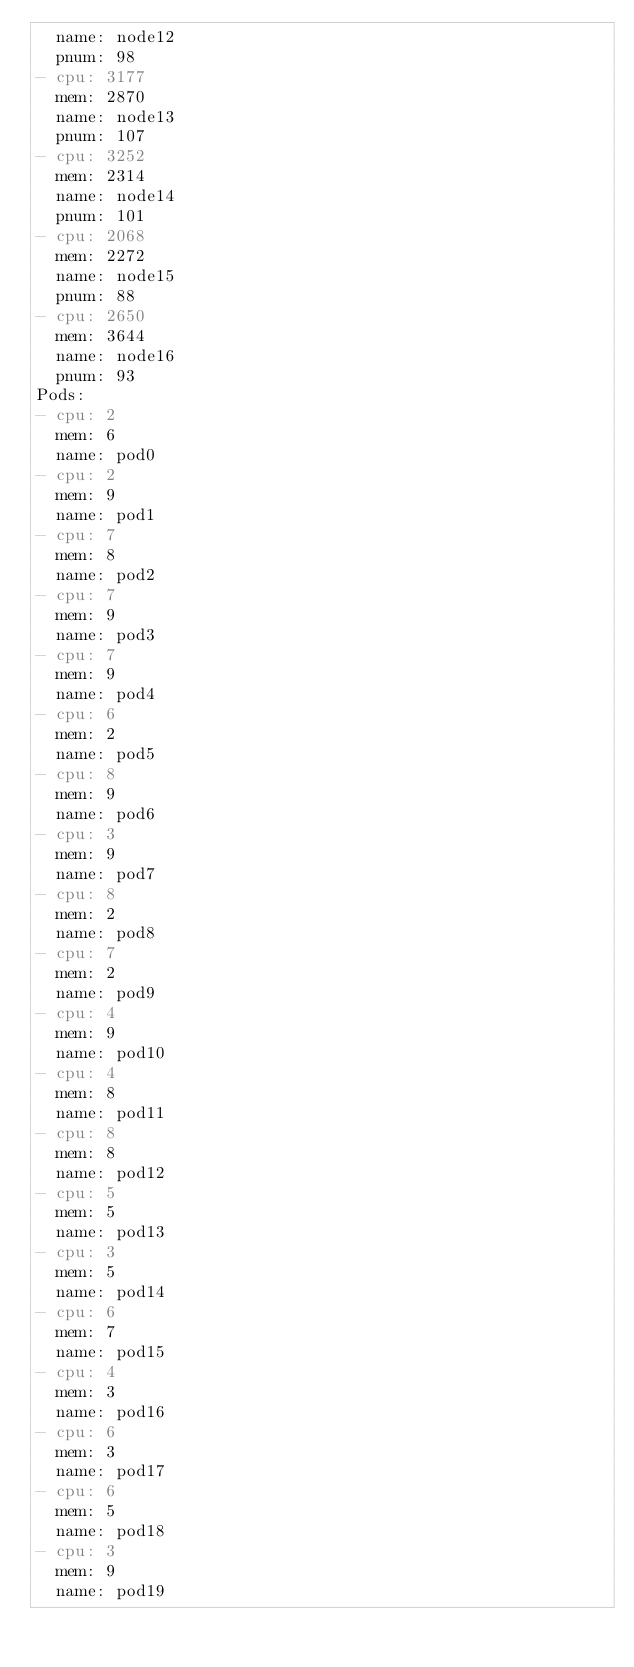Convert code to text. <code><loc_0><loc_0><loc_500><loc_500><_YAML_>  name: node12
  pnum: 98
- cpu: 3177
  mem: 2870
  name: node13
  pnum: 107
- cpu: 3252
  mem: 2314
  name: node14
  pnum: 101
- cpu: 2068
  mem: 2272
  name: node15
  pnum: 88
- cpu: 2650
  mem: 3644
  name: node16
  pnum: 93
Pods:
- cpu: 2
  mem: 6
  name: pod0
- cpu: 2
  mem: 9
  name: pod1
- cpu: 7
  mem: 8
  name: pod2
- cpu: 7
  mem: 9
  name: pod3
- cpu: 7
  mem: 9
  name: pod4
- cpu: 6
  mem: 2
  name: pod5
- cpu: 8
  mem: 9
  name: pod6
- cpu: 3
  mem: 9
  name: pod7
- cpu: 8
  mem: 2
  name: pod8
- cpu: 7
  mem: 2
  name: pod9
- cpu: 4
  mem: 9
  name: pod10
- cpu: 4
  mem: 8
  name: pod11
- cpu: 8
  mem: 8
  name: pod12
- cpu: 5
  mem: 5
  name: pod13
- cpu: 3
  mem: 5
  name: pod14
- cpu: 6
  mem: 7
  name: pod15
- cpu: 4
  mem: 3
  name: pod16
- cpu: 6
  mem: 3
  name: pod17
- cpu: 6
  mem: 5
  name: pod18
- cpu: 3
  mem: 9
  name: pod19
</code> 